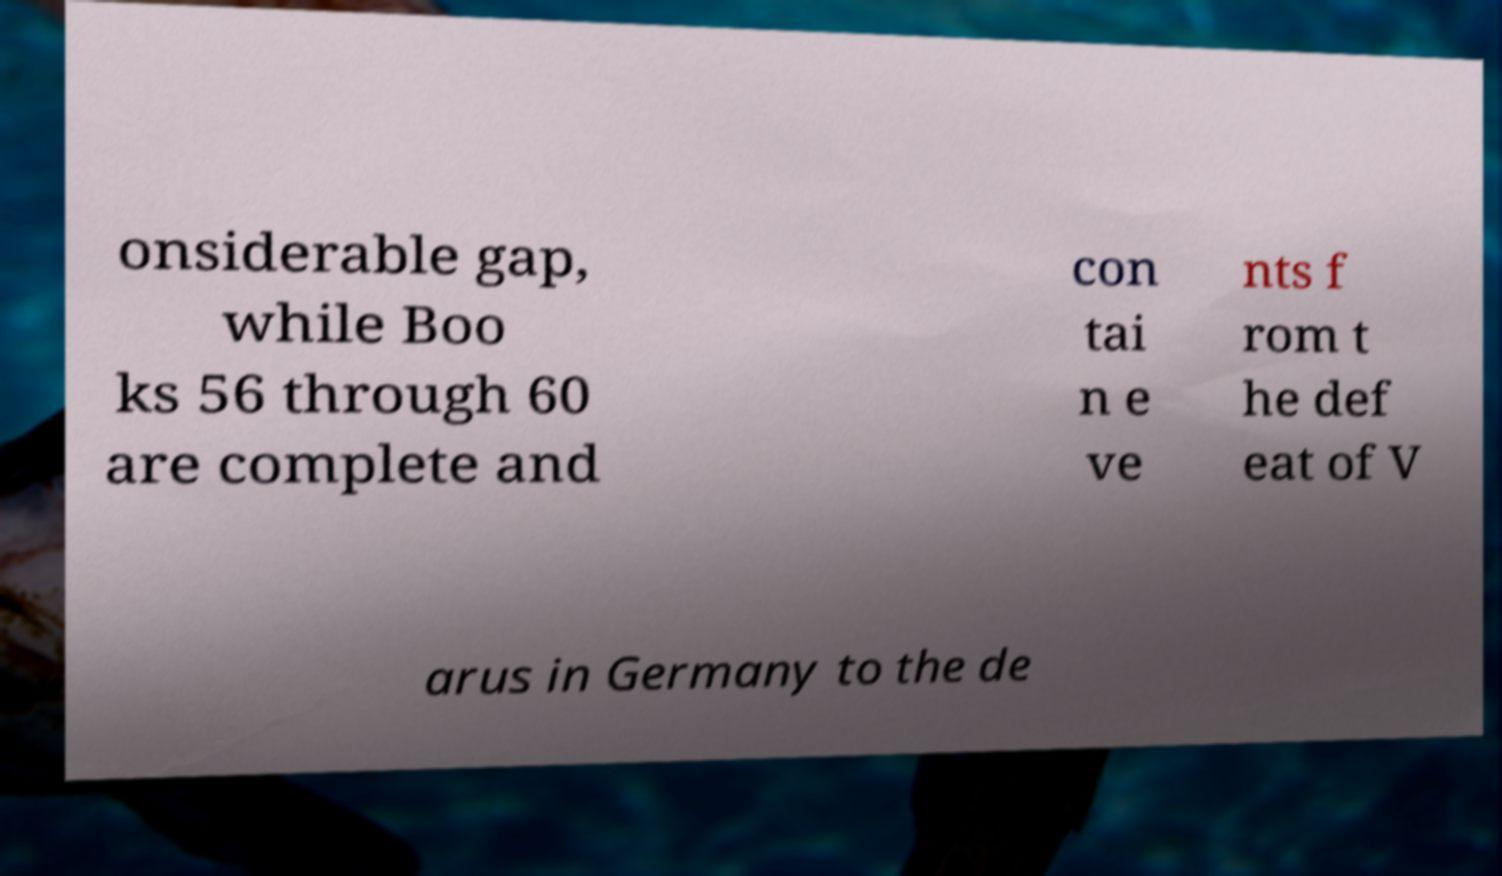I need the written content from this picture converted into text. Can you do that? onsiderable gap, while Boo ks 56 through 60 are complete and con tai n e ve nts f rom t he def eat of V arus in Germany to the de 